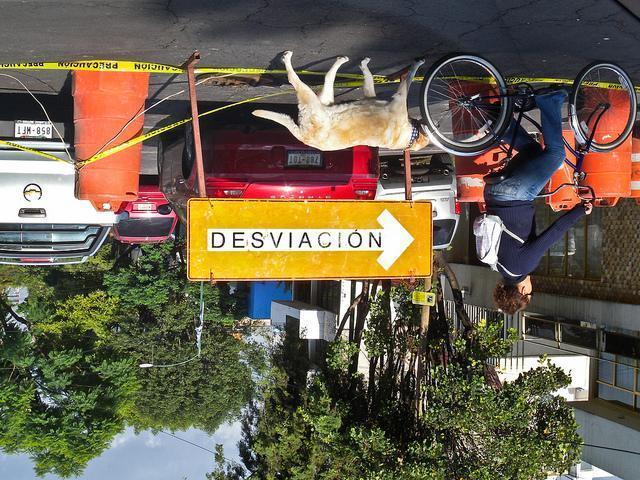How many cars are visible?
Give a very brief answer. 4. How many people can be seen?
Give a very brief answer. 1. 